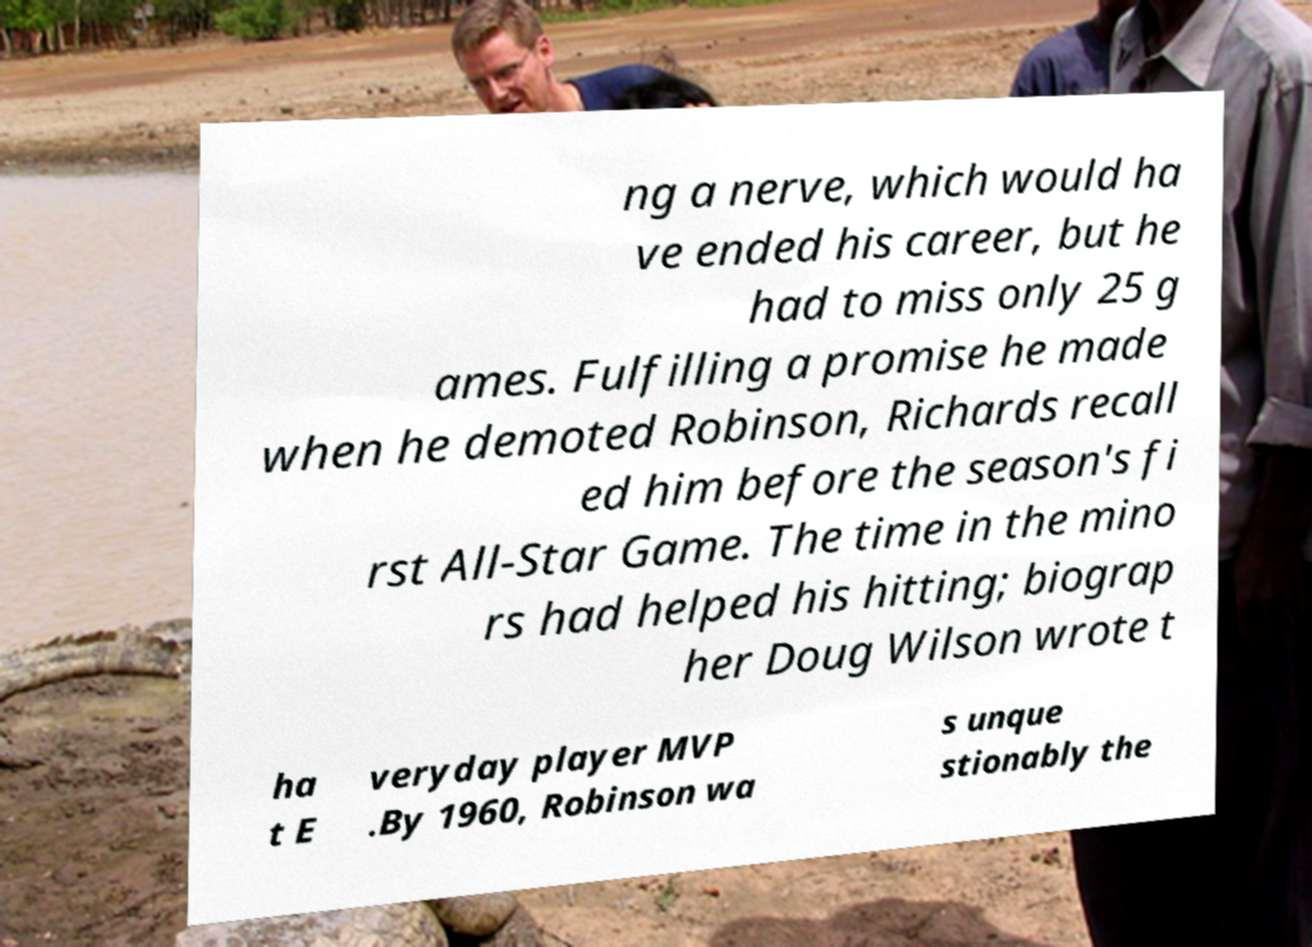What messages or text are displayed in this image? I need them in a readable, typed format. ng a nerve, which would ha ve ended his career, but he had to miss only 25 g ames. Fulfilling a promise he made when he demoted Robinson, Richards recall ed him before the season's fi rst All-Star Game. The time in the mino rs had helped his hitting; biograp her Doug Wilson wrote t ha t E veryday player MVP .By 1960, Robinson wa s unque stionably the 